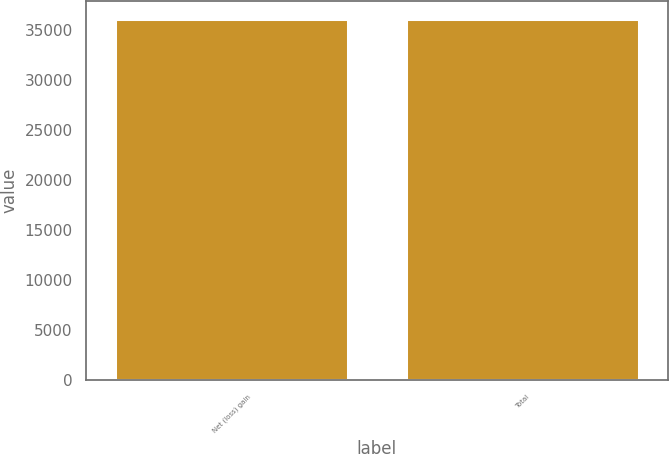<chart> <loc_0><loc_0><loc_500><loc_500><bar_chart><fcel>Net (loss) gain<fcel>Total<nl><fcel>36058<fcel>36058.1<nl></chart> 